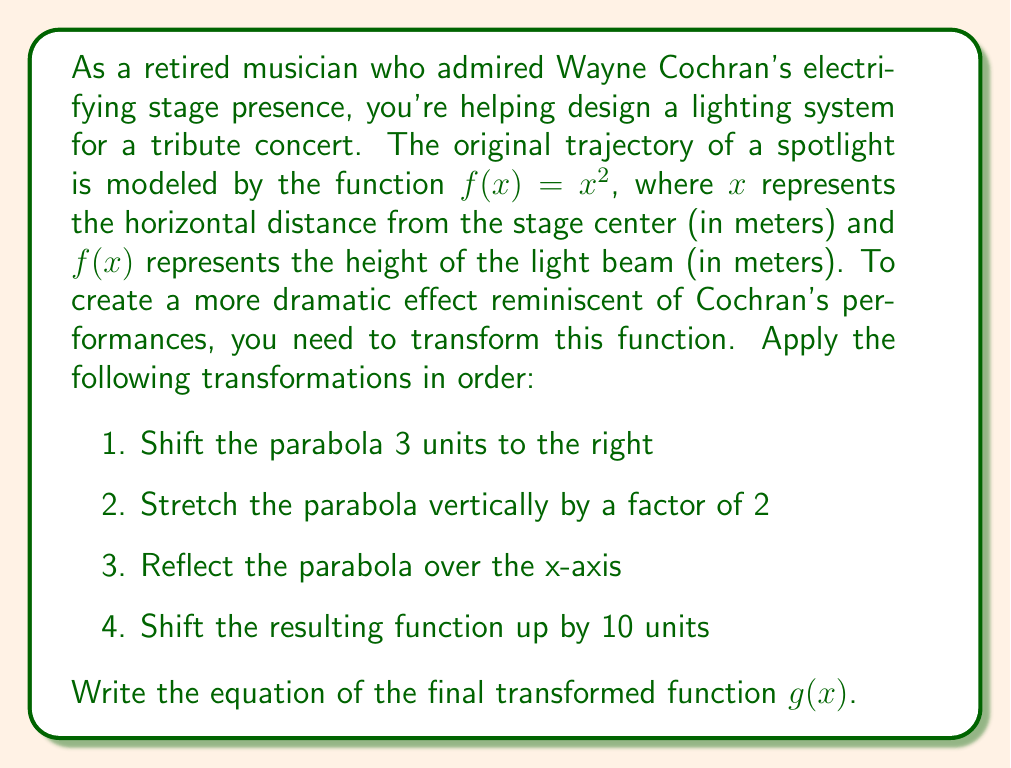Can you answer this question? Let's apply the transformations step by step:

1. Shift 3 units to the right:
   $f_1(x) = (x-3)^2$

2. Stretch vertically by a factor of 2:
   $f_2(x) = 2(x-3)^2$

3. Reflect over the x-axis:
   $f_3(x) = -2(x-3)^2$

4. Shift up by 10 units:
   $g(x) = -2(x-3)^2 + 10$

To understand these transformations:
- Shifting right by 3 units replaces $x$ with $(x-3)$
- Stretching vertically by 2 multiplies the function by 2
- Reflecting over the x-axis changes the sign of the function
- Shifting up by 10 units adds 10 to the function

The final function $g(x)$ represents the new trajectory of the spotlight, creating a more dramatic lighting effect that would suit a Wayne Cochran tribute performance.
Answer: $g(x) = -2(x-3)^2 + 10$ 